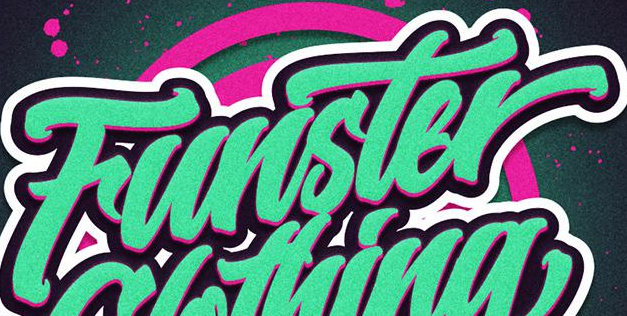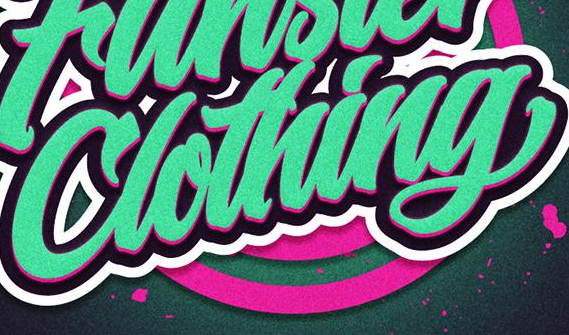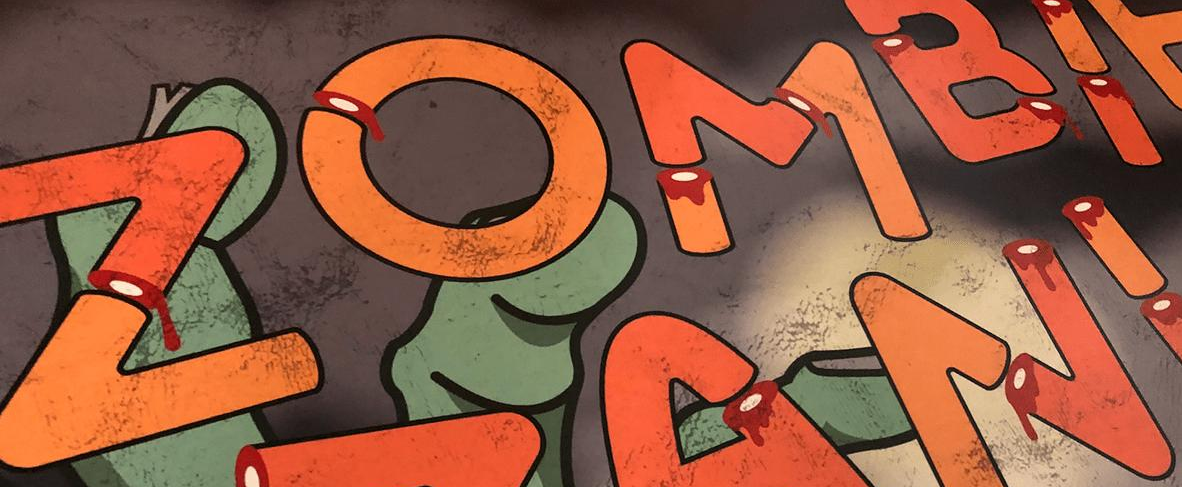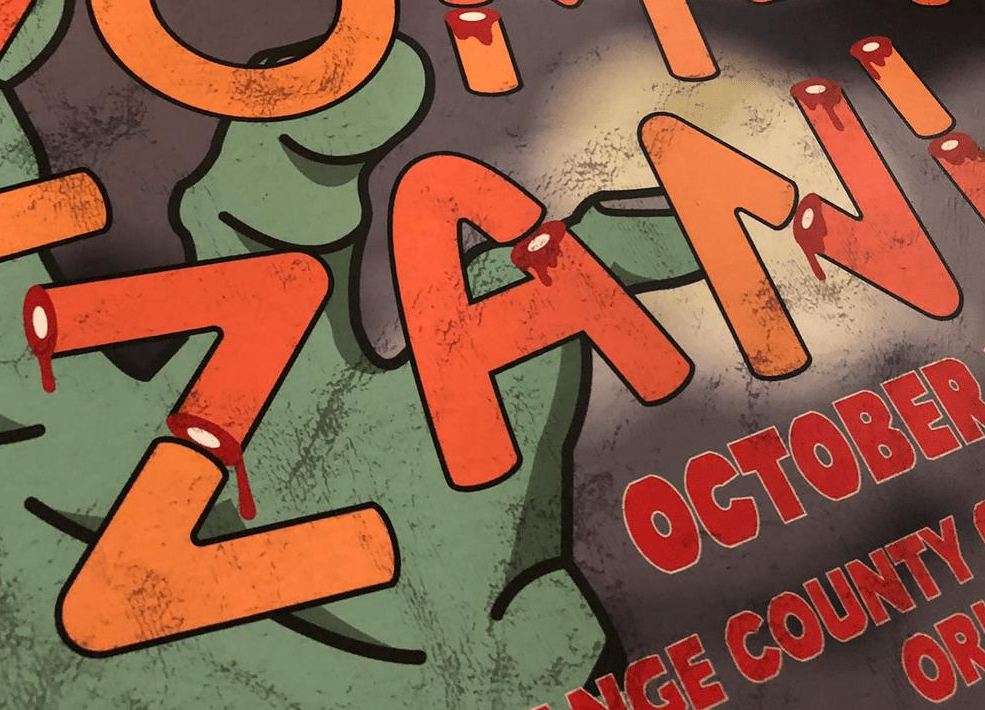Identify the words shown in these images in order, separated by a semicolon. Funster; Clothing; ZOMBI; ZANI 